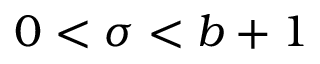<formula> <loc_0><loc_0><loc_500><loc_500>0 < \sigma < b + 1</formula> 